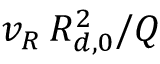Convert formula to latex. <formula><loc_0><loc_0><loc_500><loc_500>{ v _ { R } } \, R _ { d , 0 } ^ { 2 } / Q</formula> 